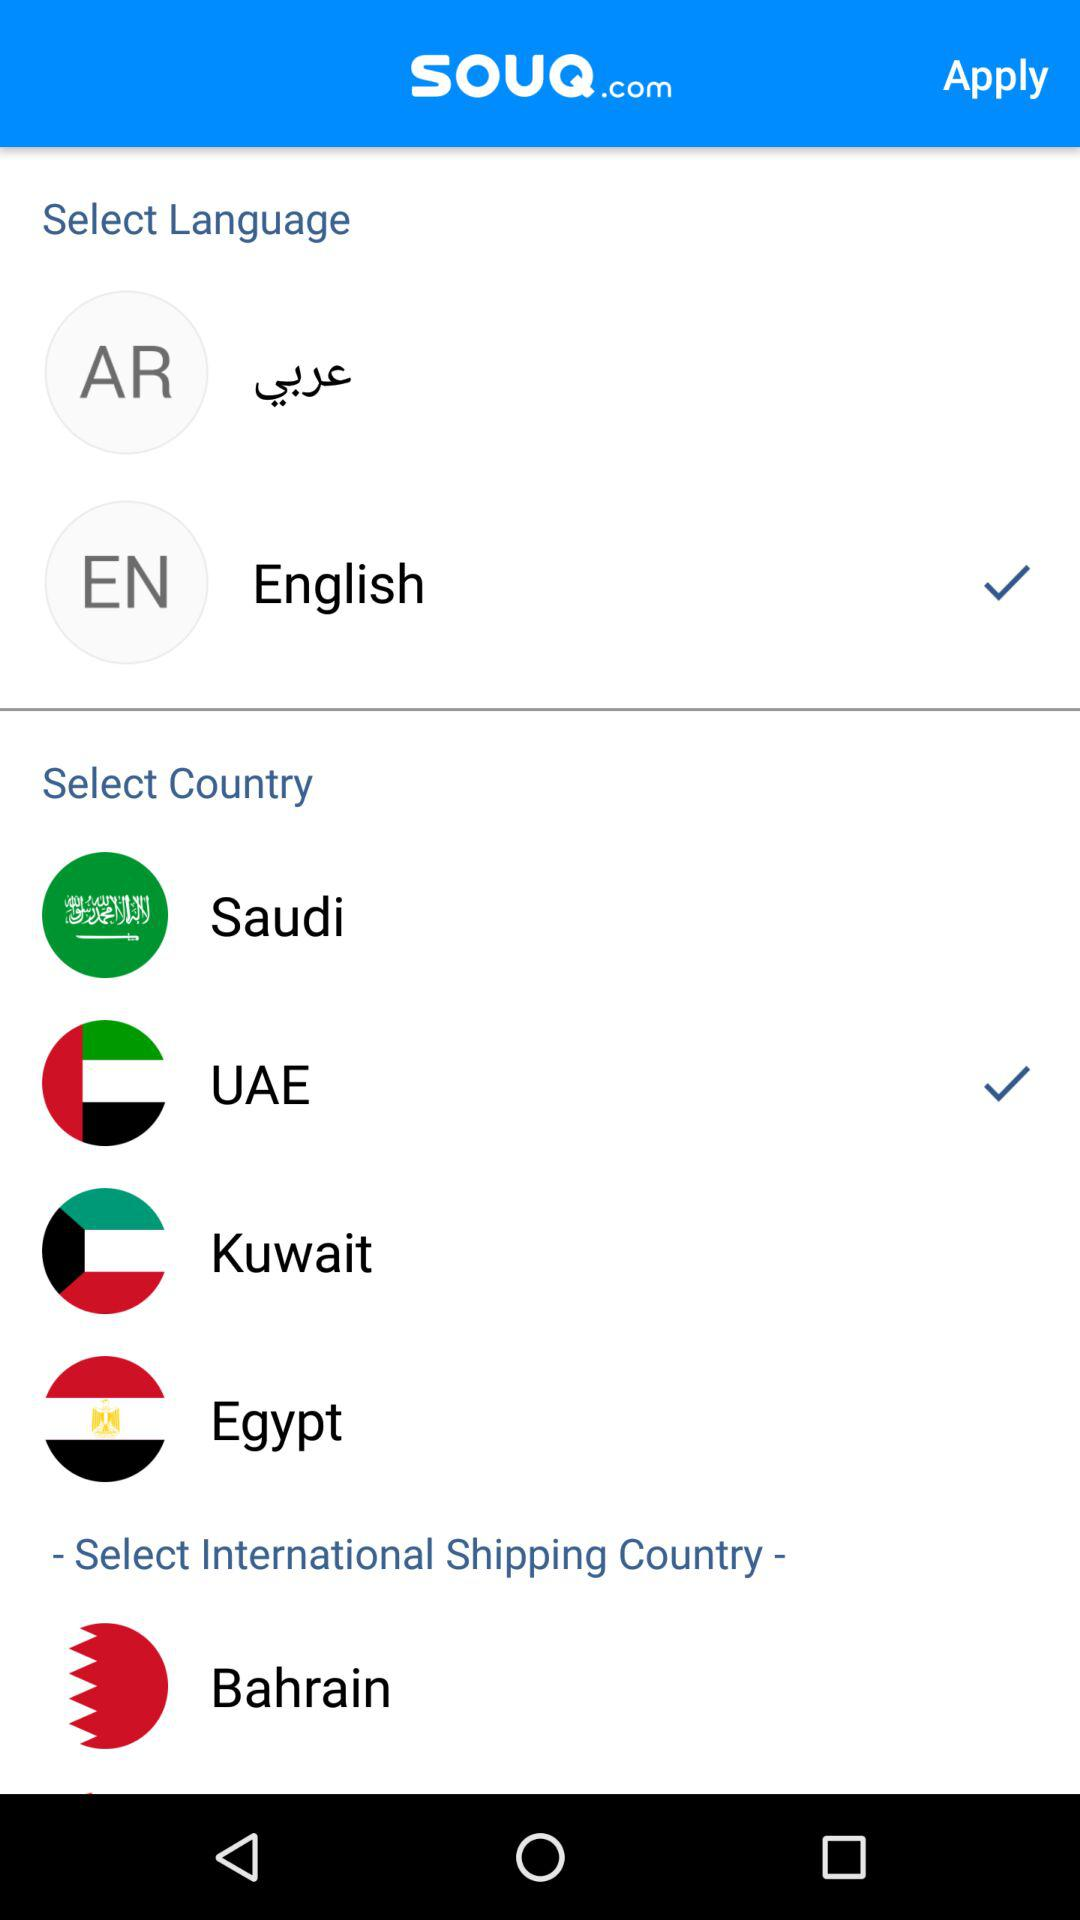Which country is the selected international shipping country?
When the provided information is insufficient, respond with <no answer>. <no answer> 